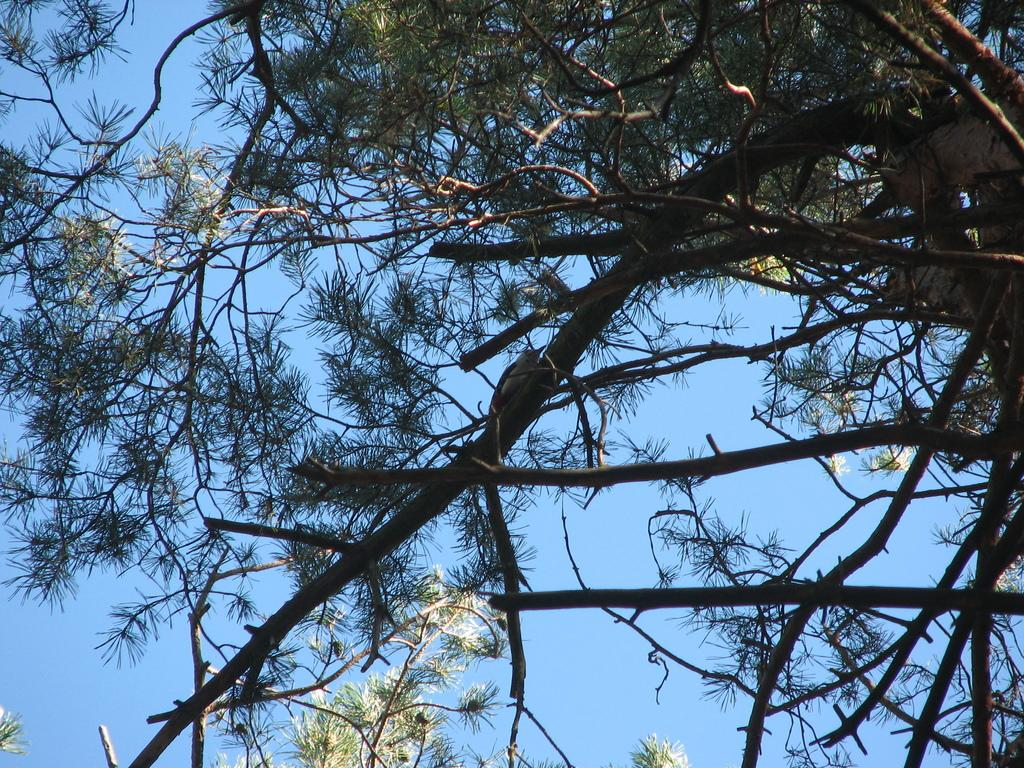What type of plant can be seen in the image? There is a tree in the image. What features of the tree are visible? The tree has branches and leaves. Is there any wildlife present in the image? Yes, there is a bird on a branch of the tree. What can be seen in the background of the image? The sky is visible in the image. How many feet are visible on the bird in the image? The image does not show the bird's feet, so it is impossible to determine how many feet are visible. What type of teeth does the tree have in the image? Trees do not have teeth, so this question cannot be answered. 